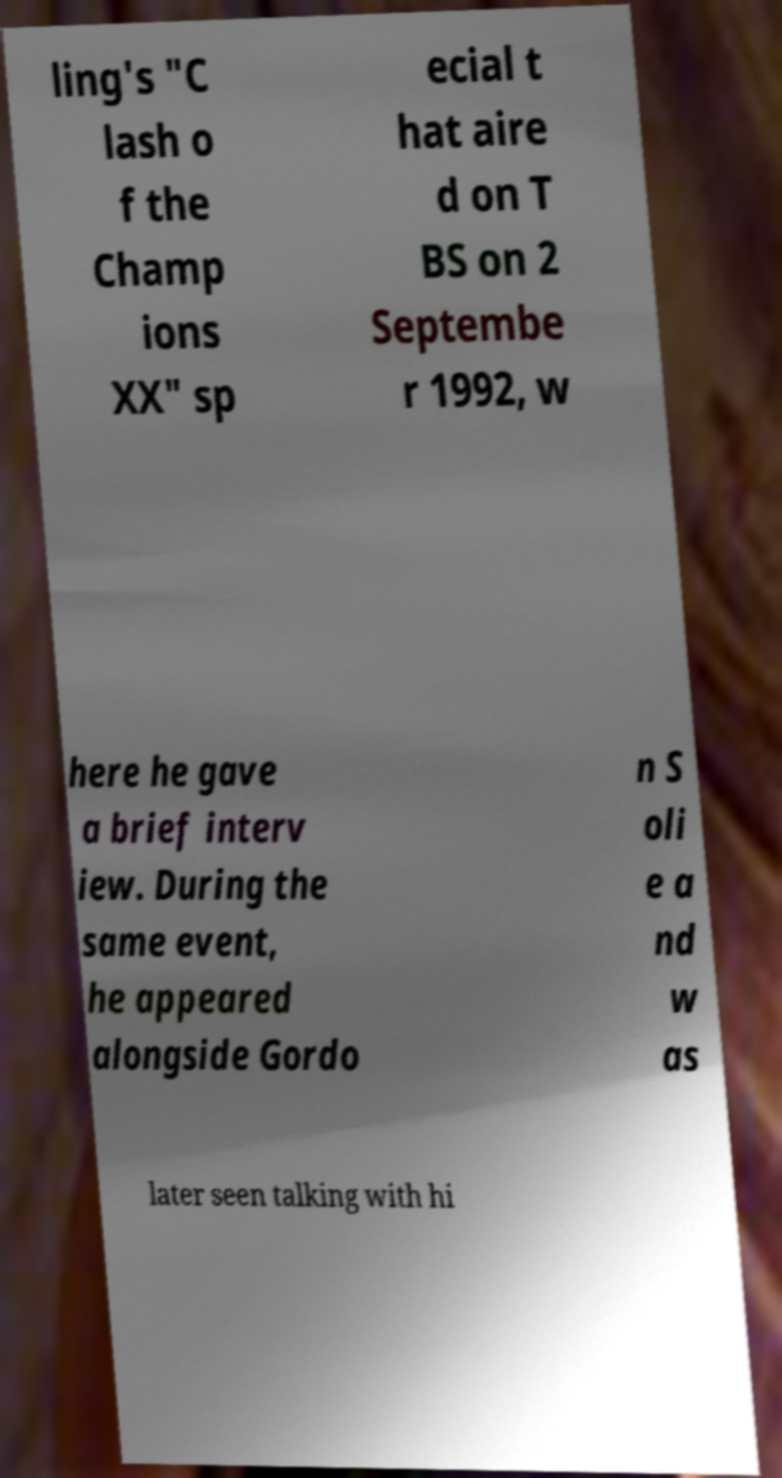Could you extract and type out the text from this image? ling's "C lash o f the Champ ions XX" sp ecial t hat aire d on T BS on 2 Septembe r 1992, w here he gave a brief interv iew. During the same event, he appeared alongside Gordo n S oli e a nd w as later seen talking with hi 